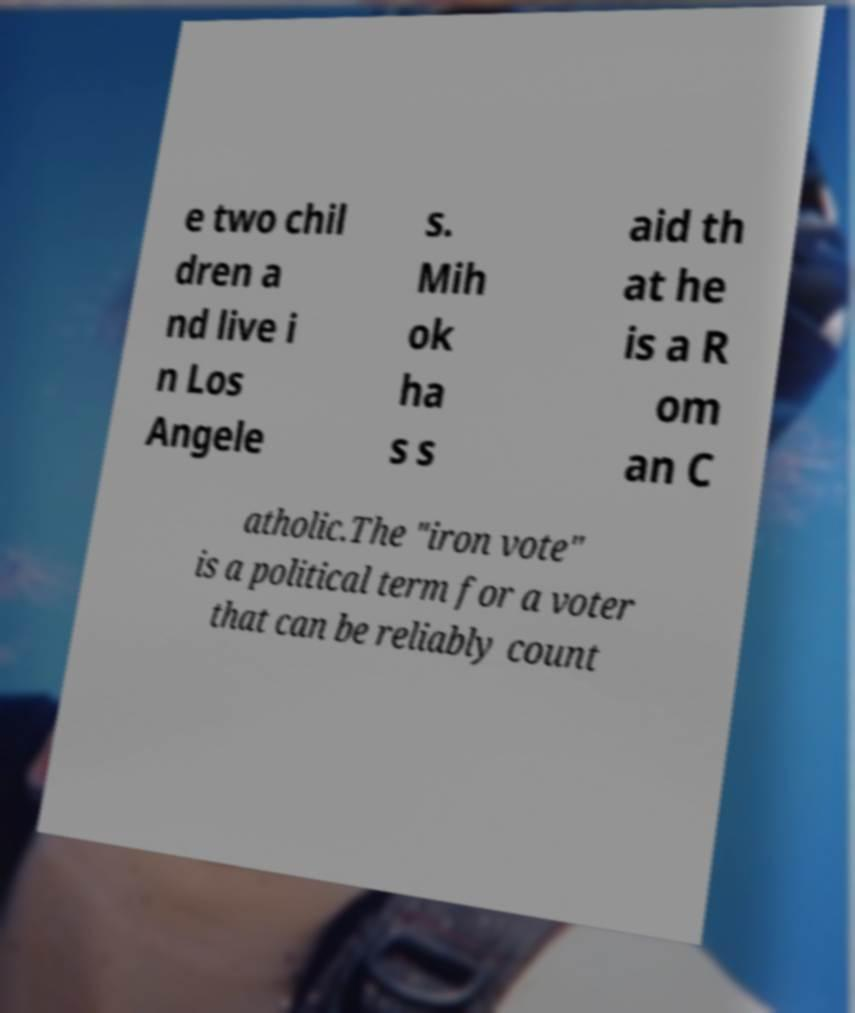Please identify and transcribe the text found in this image. e two chil dren a nd live i n Los Angele s. Mih ok ha s s aid th at he is a R om an C atholic.The "iron vote" is a political term for a voter that can be reliably count 